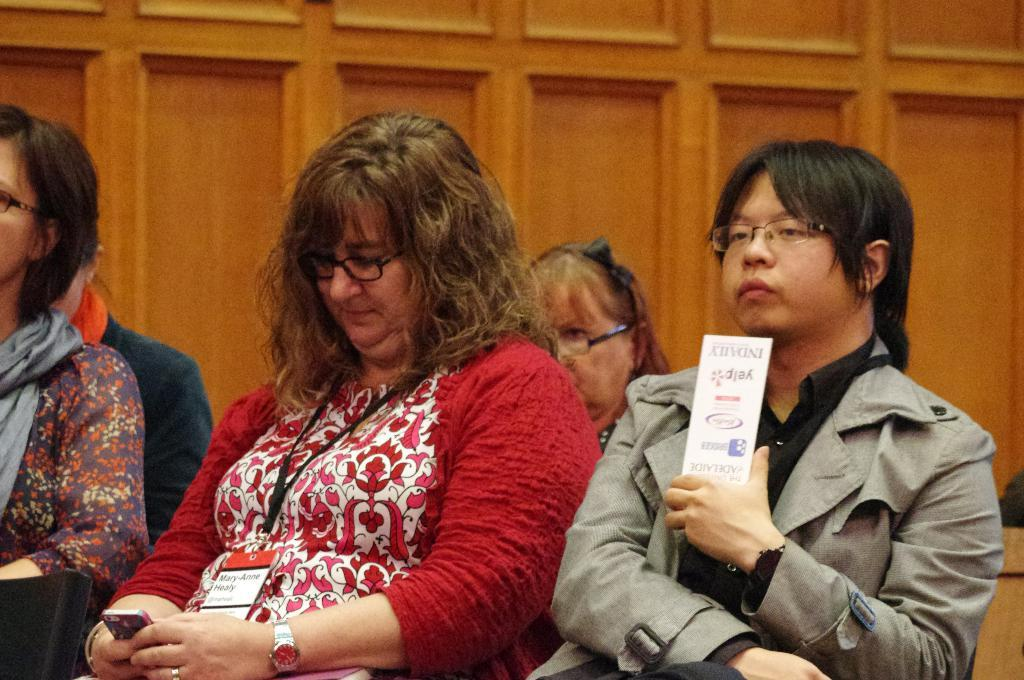What are the people in the image doing? The people in the image are sitting and holding mobile devices and papers. What objects are the people holding in the image? The people are holding mobile devices and papers in the image. How can you describe the attire of the people in the image? The people are wearing different color dresses in the image. What can be seen in the background of the image? There is a brown color wall visible in the background of the image. What type of meat is being seasoned with salt in the image? There is no meat or salt present in the image; it features people sitting and holding mobile devices and papers. 